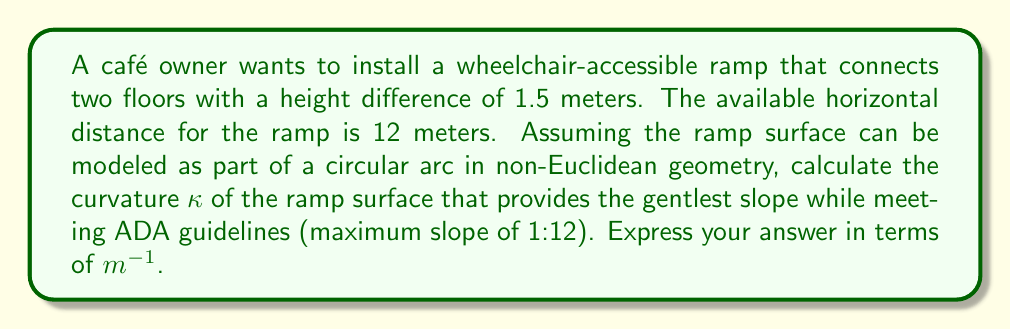Can you solve this math problem? Let's approach this step-by-step:

1) First, we need to understand what curvature means in this context. In non-Euclidean geometry, curvature $\kappa$ is the inverse of the radius $R$ of the circular arc: $\kappa = \frac{1}{R}$.

2) The ADA guideline of a maximum 1:12 slope means that for every 12 units of horizontal distance, there can be at most 1 unit of vertical rise. In our case:
   Horizontal distance = 12 m
   Vertical rise = 1.5 m
   Slope = 1.5 / 12 = 1:8, which meets the ADA guideline.

3) We can model this ramp as part of a circular arc. Let's draw a right triangle where:
   - The hypotenuse is the radius $R$ of the circular arc
   - One leg is the horizontal distance (12 m)
   - The other leg is $R - 1.5$ m (the difference between the radius and the vertical rise)

4) Using the Pythagorean theorem:
   $R^2 = 12^2 + (R - 1.5)^2$

5) Expanding this equation:
   $R^2 = 144 + R^2 - 3R + 2.25$

6) Simplifying:
   $3R = 146.25$

7) Solving for $R$:
   $R = 48.75$ m

8) Now we can calculate the curvature:
   $\kappa = \frac{1}{R} = \frac{1}{48.75} = 0.0205128205128205$ $m^{-1}$

This curvature provides the gentlest slope possible given the constraints, while still meeting ADA guidelines.
Answer: $\kappa \approx 0.0205$ $m^{-1}$ 